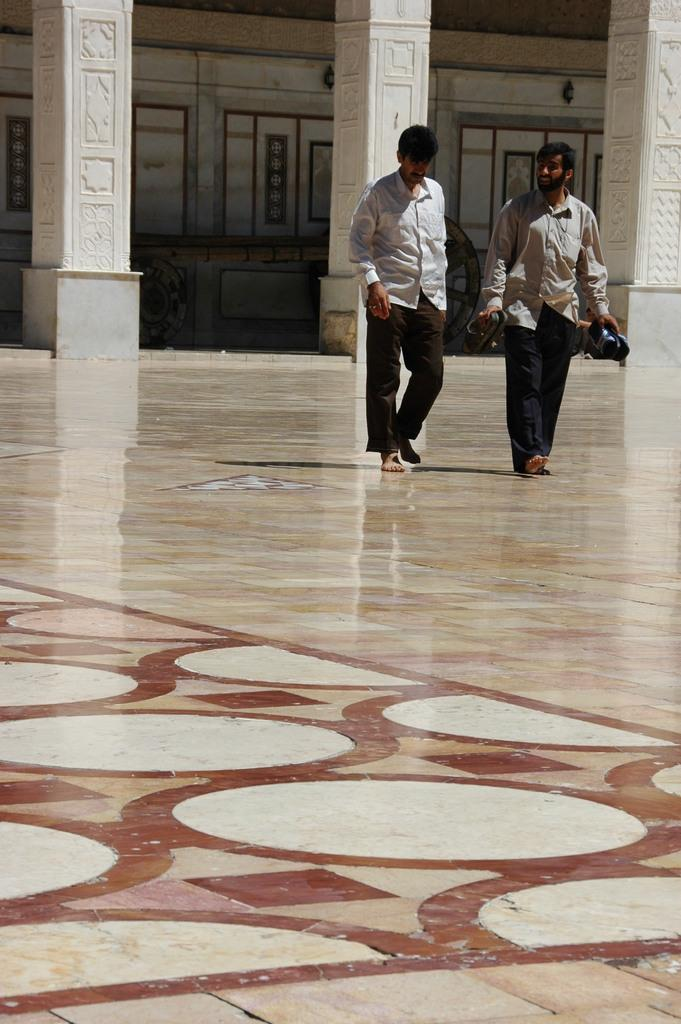How many people are present in the image? There are two persons in the image. What are the persons doing in the image? The persons are walking on the floor. Can you describe the object being held by one of the persons? One of the persons is holding an object in their hand. What can be seen in the background of the image? There are pillars and a wall in the background of the image. What type of spy equipment can be seen in the hands of the person in the image? There is no spy equipment visible in the image; one of the persons is simply holding an object in their hand. Is there a battle taking place in the image? There is no battle depicted in the image; it shows two people walking on the floor. 